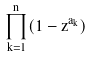Convert formula to latex. <formula><loc_0><loc_0><loc_500><loc_500>\prod _ { k = 1 } ^ { n } ( 1 - z ^ { a _ { k } } )</formula> 